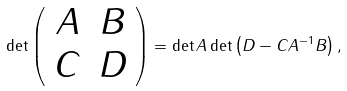<formula> <loc_0><loc_0><loc_500><loc_500>\det \left ( \begin{array} { c c } A & B \\ C & D \end{array} \right ) = \det A \det \left ( D - C A ^ { - 1 } B \right ) ,</formula> 